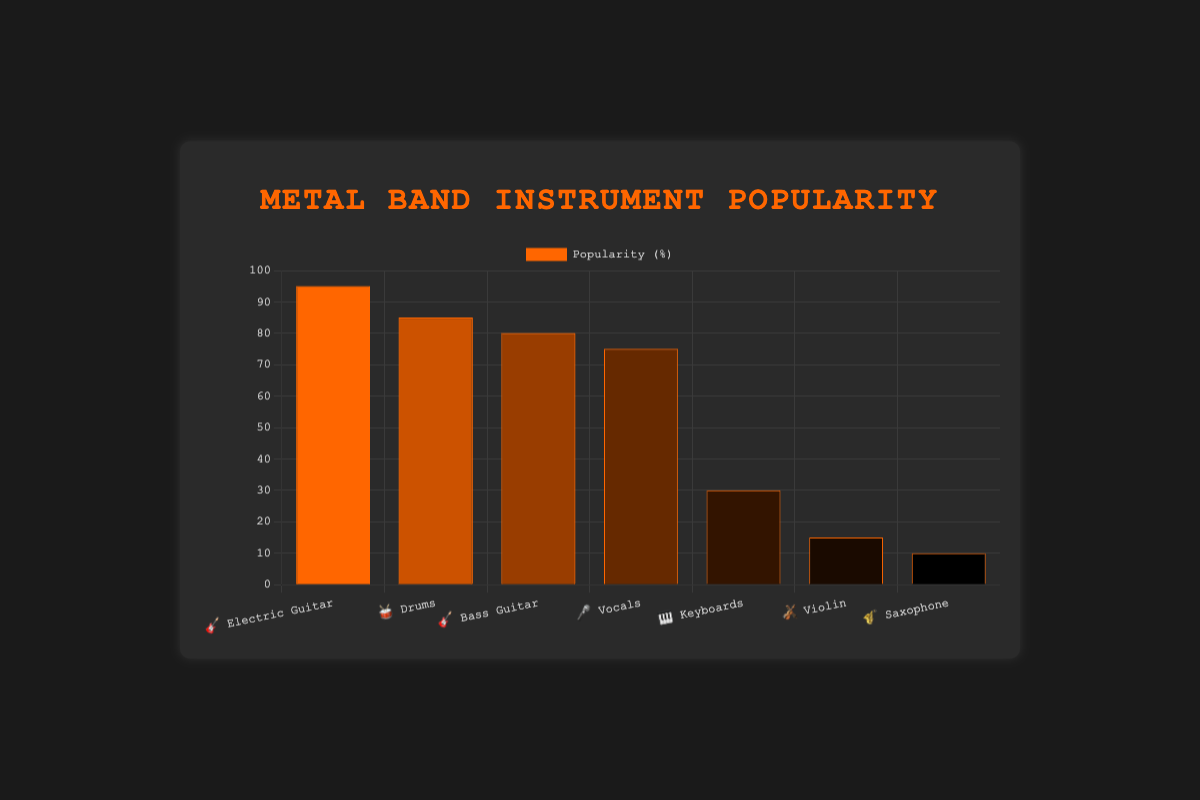Which instrument is the most popular? The figure shows the popularity of various instruments in metal bands with their respective emojis, where the highest bar indicates the most popular instrument. The Electric Guitar has the highest popularity at 95%.
Answer: Electric Guitar 🎸 What is the least popular instrument? To find the least popular instrument, look for the instrument with the smallest bar in the chart. The Saxophone has the lowest popularity at 10%.
Answer: Saxophone 🎷 What is the difference in popularity between Electric Guitar and Bass Guitar? The popularity of the Electric Guitar is 95%, and the popularity of the Bass Guitar is 80%. Subtract the Bass Guitar popularity from the Electric Guitar popularity (95% - 80% = 15%).
Answer: 15% Which instrument is more popular, Drums or Vocals? Compare the heights of the bars for Drums and Vocals. The figure shows Drums with 85% popularity and Vocals with 75% popularity. Drums have a higher popularity.
Answer: Drums 🥁 What is the total popularity percentage of all instruments combined? Sum the popularity percentages of all instruments: 95% (Electric Guitar) + 85% (Drums) + 80% (Bass Guitar) + 75% (Vocals) + 30% (Keyboards) + 15% (Violin) + 10% (Saxophone) = 390%.
Answer: 390% How many instruments have a popularity of 50% or higher? Count the bars that represent instruments with at least 50% popularity. Electric Guitar, Drums, Bass Guitar, and Vocals all meet this criterion, resulting in 4 instruments.
Answer: 4 Which instrument has the closest popularity to Keyboards? Check the popularity percentages and find the one closest to 30% (Keyboards). The Violin has a popularity of 15%, which is closer to 30% than the Saxophone at 10%.
Answer: Violin 🎻 If the popularity of Violin doubled, what would its new popularity be? The current popularity of the Violin is 15%. If it doubled, multiply 15% by 2 to get 30%.
Answer: 30% What's the average popularity of Drums, Bass Guitar, and Keyboards? Find the sum of the popularity percentages for Drums (85%), Bass Guitar (80%), and Keyboards (30%), then divide by 3: (85% + 80% + 30%) / 3 = 65%.
Answer: 65% Which two instruments have the exact same popularity percentage? Look for two bars with the same height. Electric Guitar and Bass Guitar both have the popularity percentage of 80%.
Answer: Bass Guitar 🎸 and Electric Guitar 🎸 